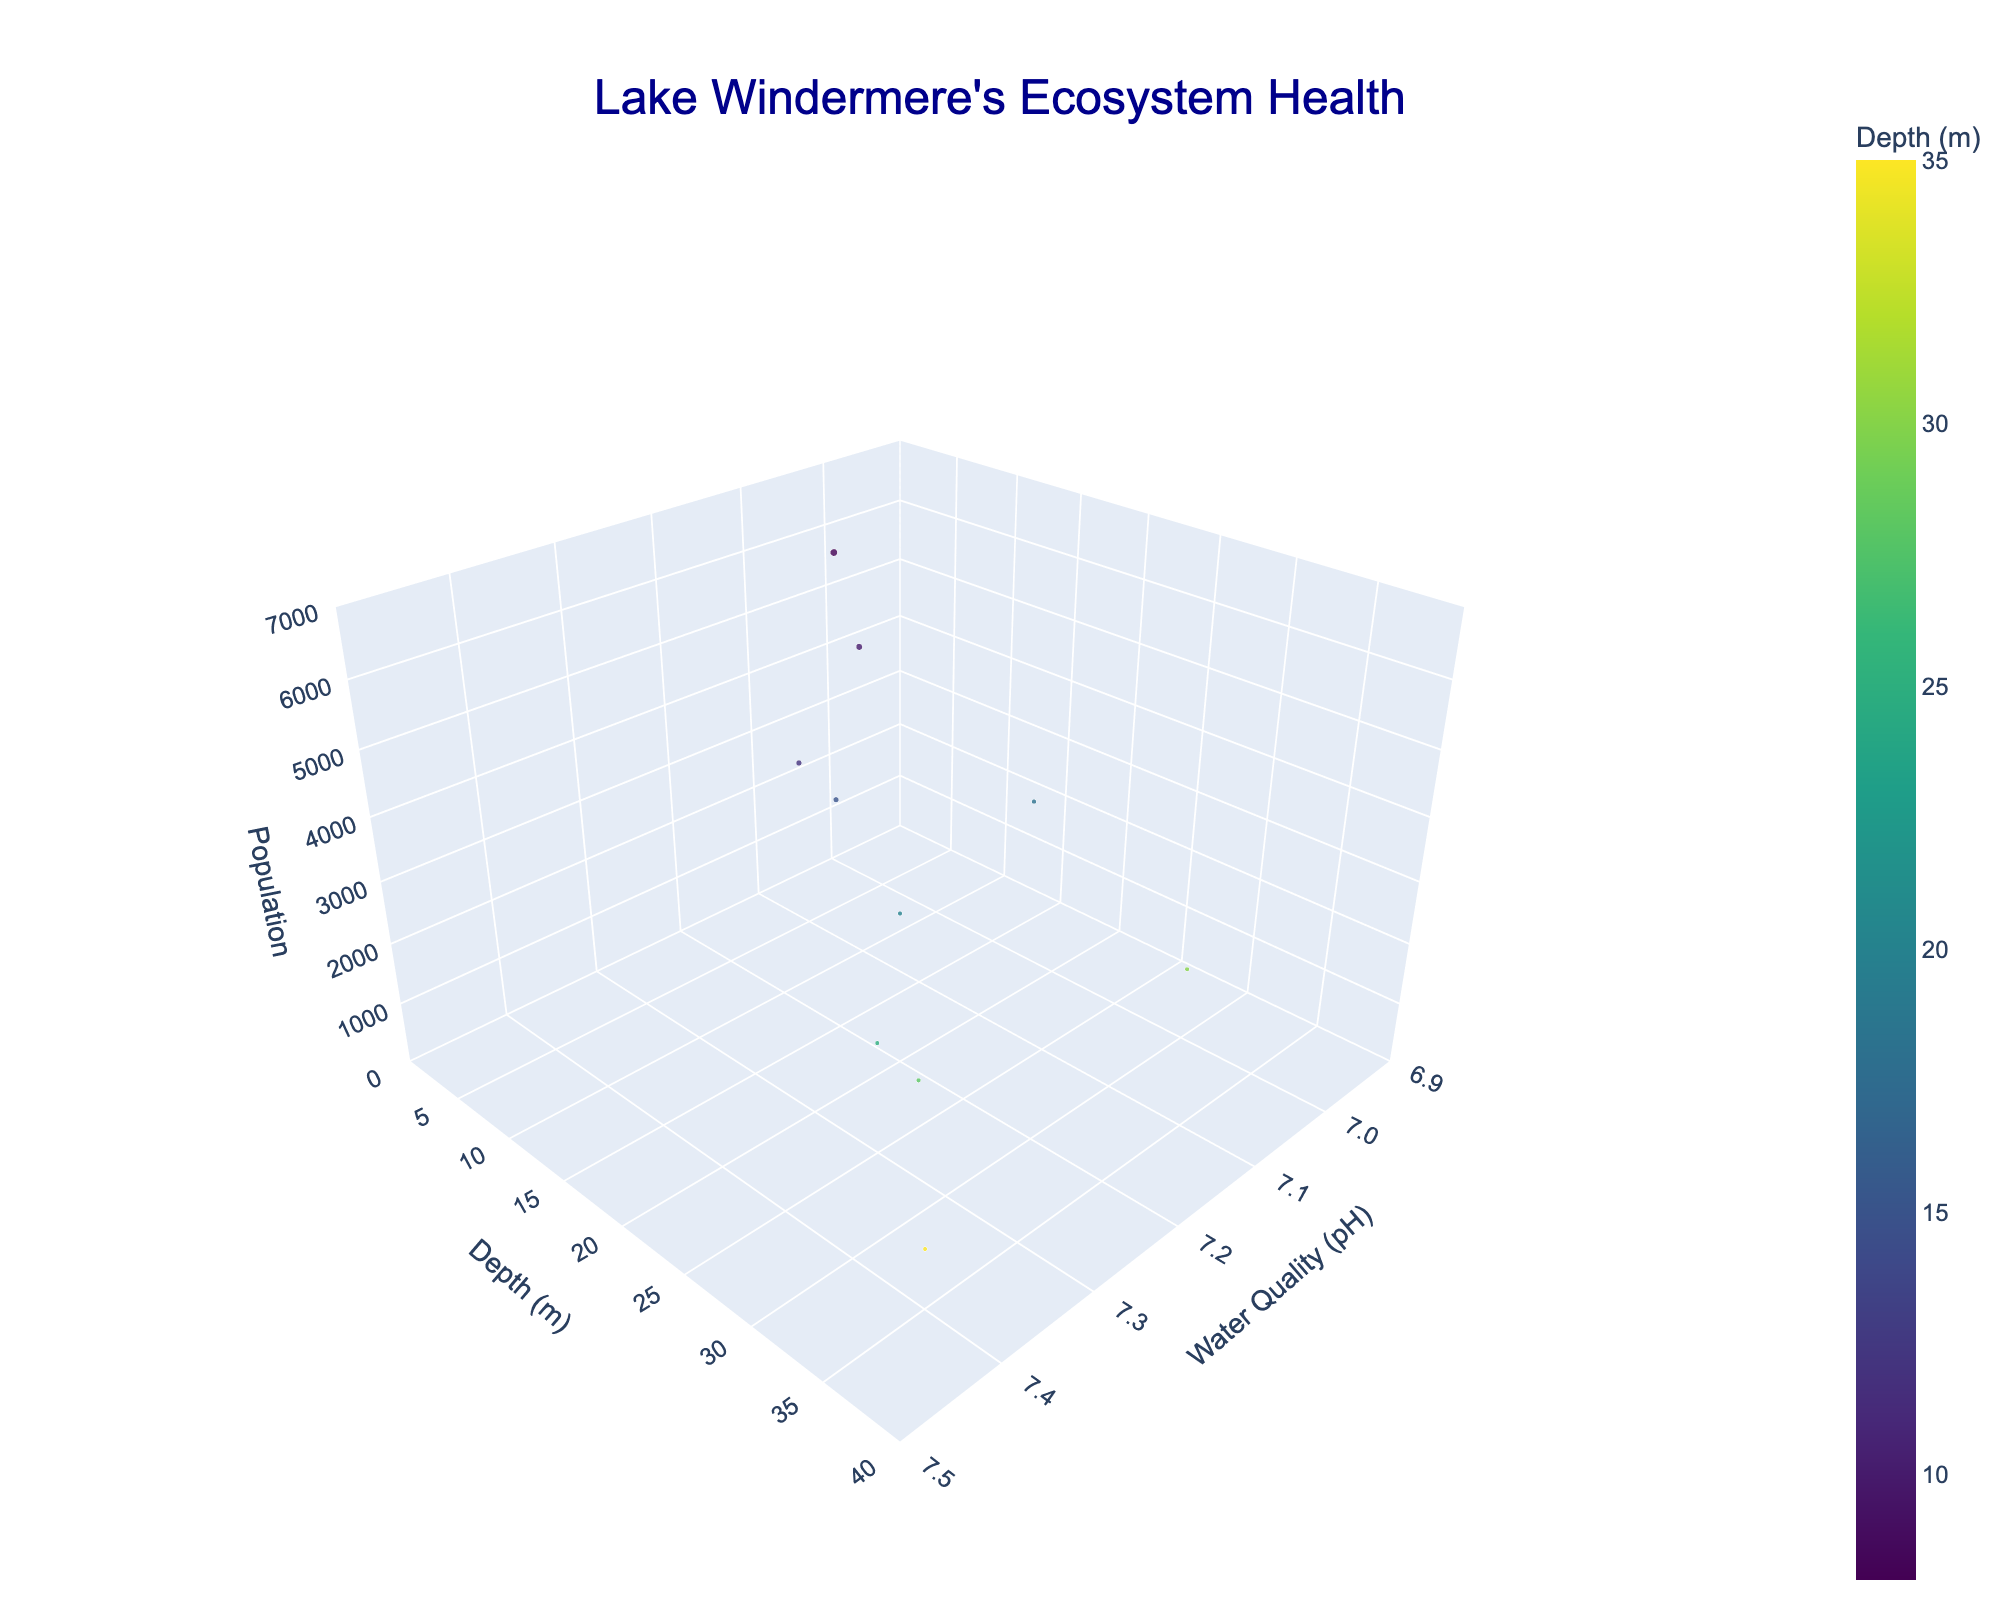how many fish species are shown in the chart? There are 10 different markers on the chart, each representing a different fish species as listed in the legend or hover text.
Answer: 10 which fish species has the highest population? Look for the marker with the highest elevation along the Z-axis which represents population. By referencing the hover text or the size of the marker, we see that 'Roach' has the highest population.
Answer: Roach what is the water quality for the Atlantic Salmon? Find the marker for 'Atlantic Salmon' and read the value on the X-axis which represents water quality (pH). The hover text also shows this information.
Answer: 7.2 which species prefers the deepest habitat? Look for the marker positioned furthest to the right on the Y-axis. By referencing the hover text, 'Arctic Charr' is located in the deepest depth.
Answer: Arctic Charr how does the population of the European Perch compare with the European Eel? Compare the elevations (Z-axis) of the markers for 'European Perch' and 'European Eel'. The 'European Perch' is much higher, indicating a larger population.
Answer: European Perch has a larger population what is the median depth inhabited by the fish species shown? List the depths (8, 10, 12, 15, 18, 20, 25, 28, 30, 35) and find the median value. Since there are 10 values, the median will be the average of the 5th and 6th values, (18+20)/2.
Answer: 19.5 which fish species is found at a pH of 7.3? Identify the markers along the X-axis at pH 7.3 and read the species from the hover text. 'Northern Pike' and 'European Whitefish' are at this pH level.
Answer: Northern Pike and European Whitefish what is the average population of fish species living at a depth shallower than 20 meters? Identify markers for fish species at depths less than 20 meters (five species: Atlantic Salmon, Brown Trout, European Perch, Roach, and Common Bream). Calculate the average population: (2500 + 3800 + 5200 + 6500 + 4100) / 5.
Answer: 4420 which fish species are found in water with a pH of 7.0? Identify the markers along the X-axis at pH 7.0 and read the species from the hover text. 'European Eel' and 'Tench' are at this pH level.
Answer: European Eel and Tench which has a smaller population, the Arctic Charr or the European Whitefish? Compare the elevations (Z-axis) of the markers for 'Arctic Charr' and 'European Whitefish'. The 'Arctic Charr' is lower, indicating a smaller population.
Answer: Arctic Charr 